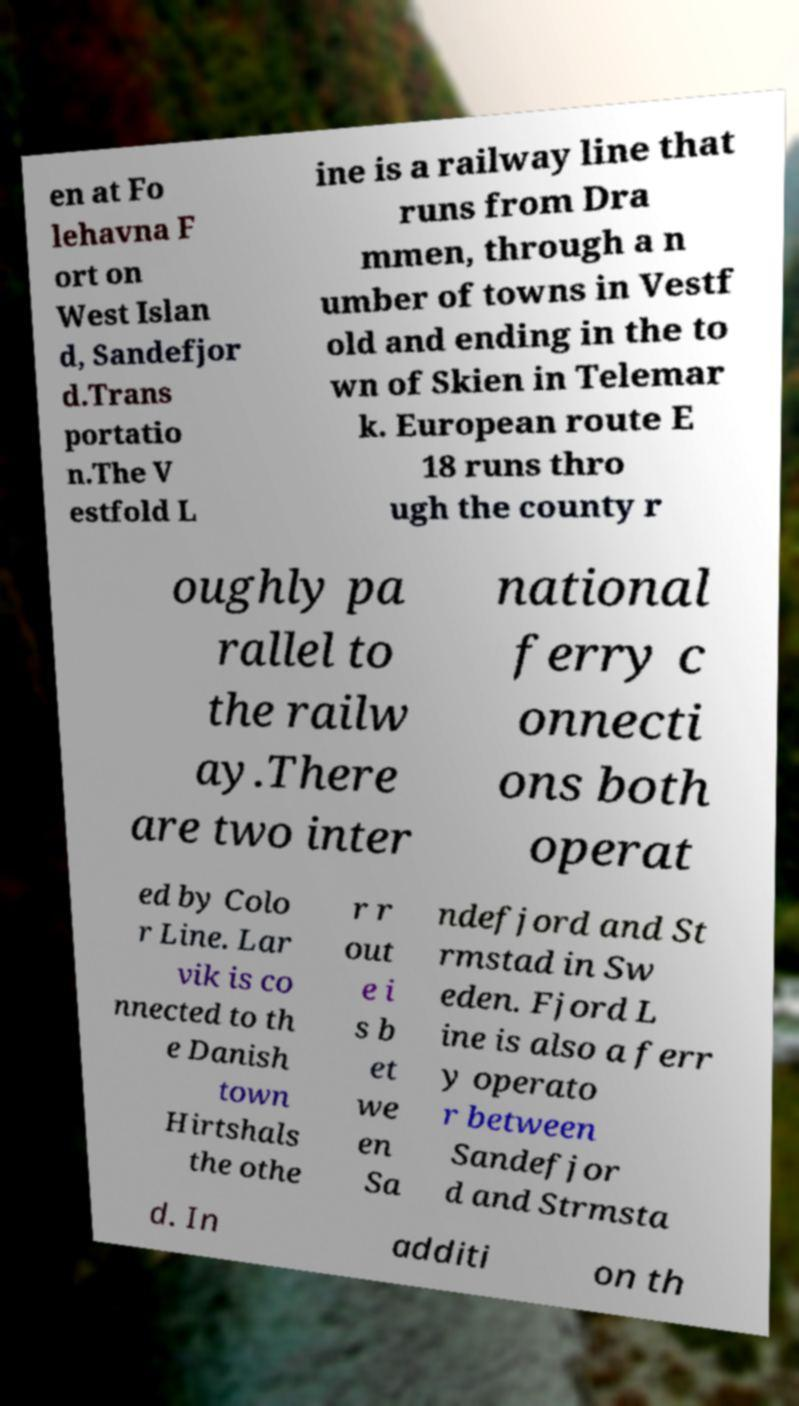I need the written content from this picture converted into text. Can you do that? en at Fo lehavna F ort on West Islan d, Sandefjor d.Trans portatio n.The V estfold L ine is a railway line that runs from Dra mmen, through a n umber of towns in Vestf old and ending in the to wn of Skien in Telemar k. European route E 18 runs thro ugh the county r oughly pa rallel to the railw ay.There are two inter national ferry c onnecti ons both operat ed by Colo r Line. Lar vik is co nnected to th e Danish town Hirtshals the othe r r out e i s b et we en Sa ndefjord and St rmstad in Sw eden. Fjord L ine is also a ferr y operato r between Sandefjor d and Strmsta d. In additi on th 